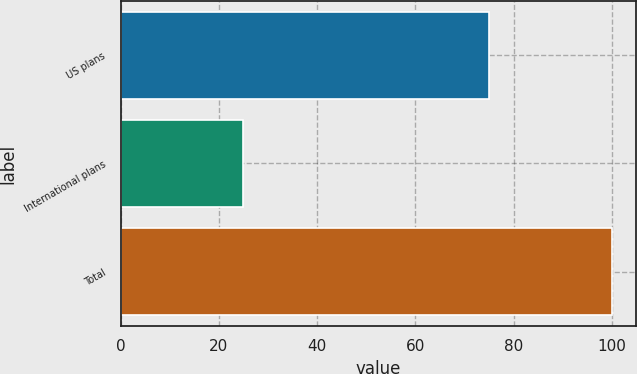<chart> <loc_0><loc_0><loc_500><loc_500><bar_chart><fcel>US plans<fcel>International plans<fcel>Total<nl><fcel>75<fcel>25<fcel>100<nl></chart> 